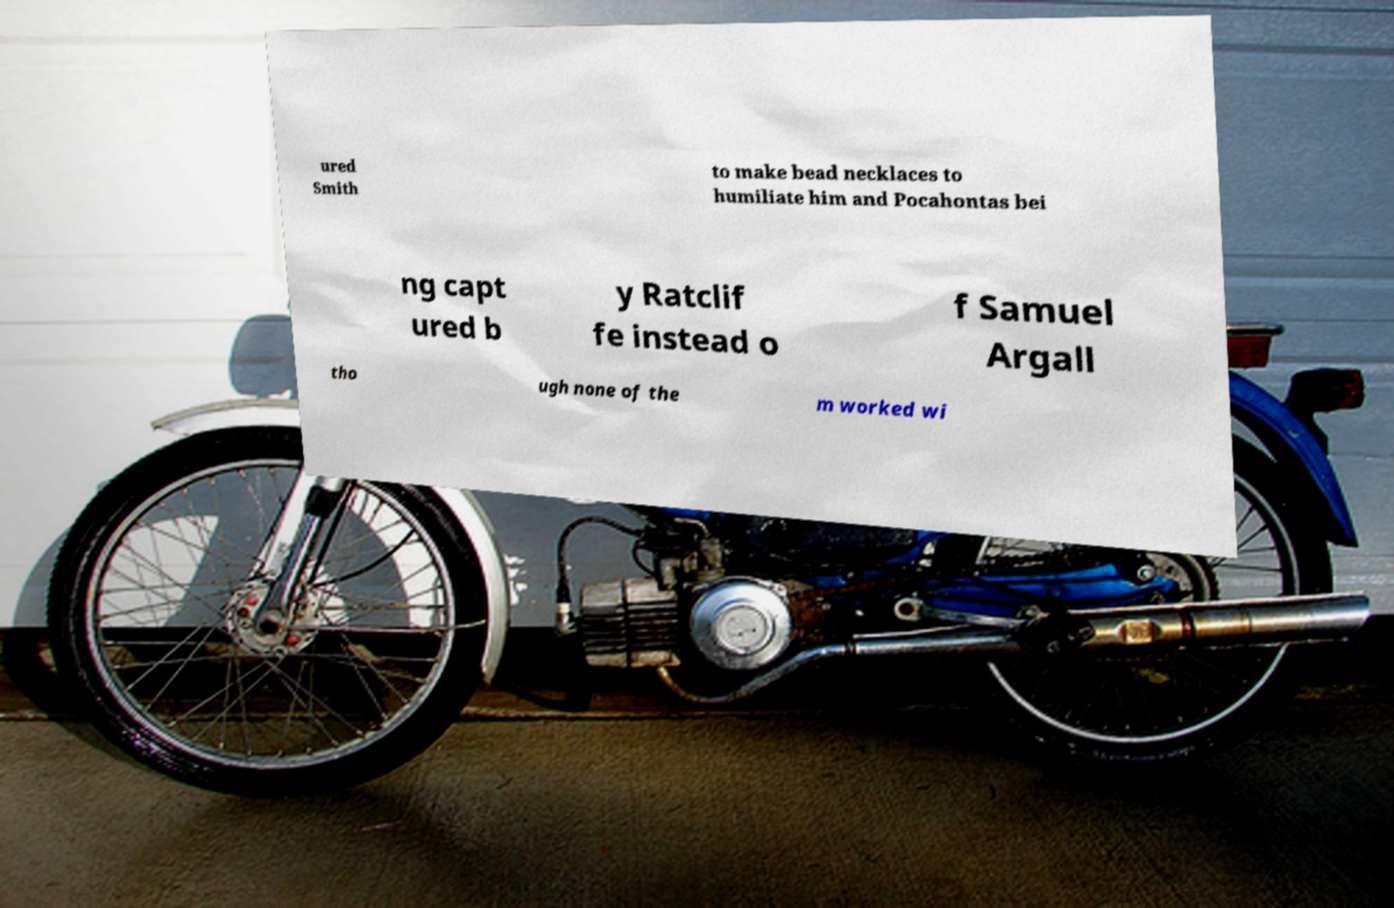What messages or text are displayed in this image? I need them in a readable, typed format. ured Smith to make bead necklaces to humiliate him and Pocahontas bei ng capt ured b y Ratclif fe instead o f Samuel Argall tho ugh none of the m worked wi 